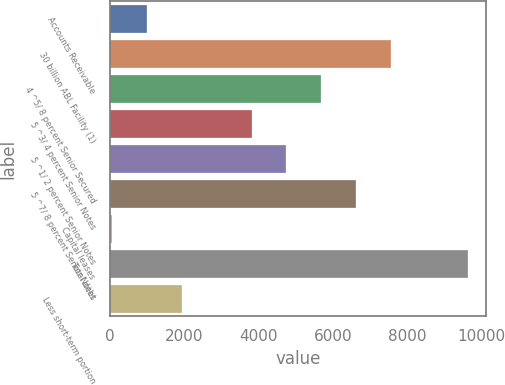<chart> <loc_0><loc_0><loc_500><loc_500><bar_chart><fcel>Accounts Receivable<fcel>30 billion ABL Facility (1)<fcel>4 ^5/ 8 percent Senior Secured<fcel>5 ^3/ 4 percent Senior Notes<fcel>5 ^1/ 2 percent Senior Notes<fcel>5 ^7/ 8 percent Senior Notes<fcel>Capital leases<fcel>Total debt<fcel>Less short-term portion<nl><fcel>1004.3<fcel>7565.4<fcel>5690.8<fcel>3816.2<fcel>4753.5<fcel>6628.1<fcel>67<fcel>9654.3<fcel>1941.6<nl></chart> 